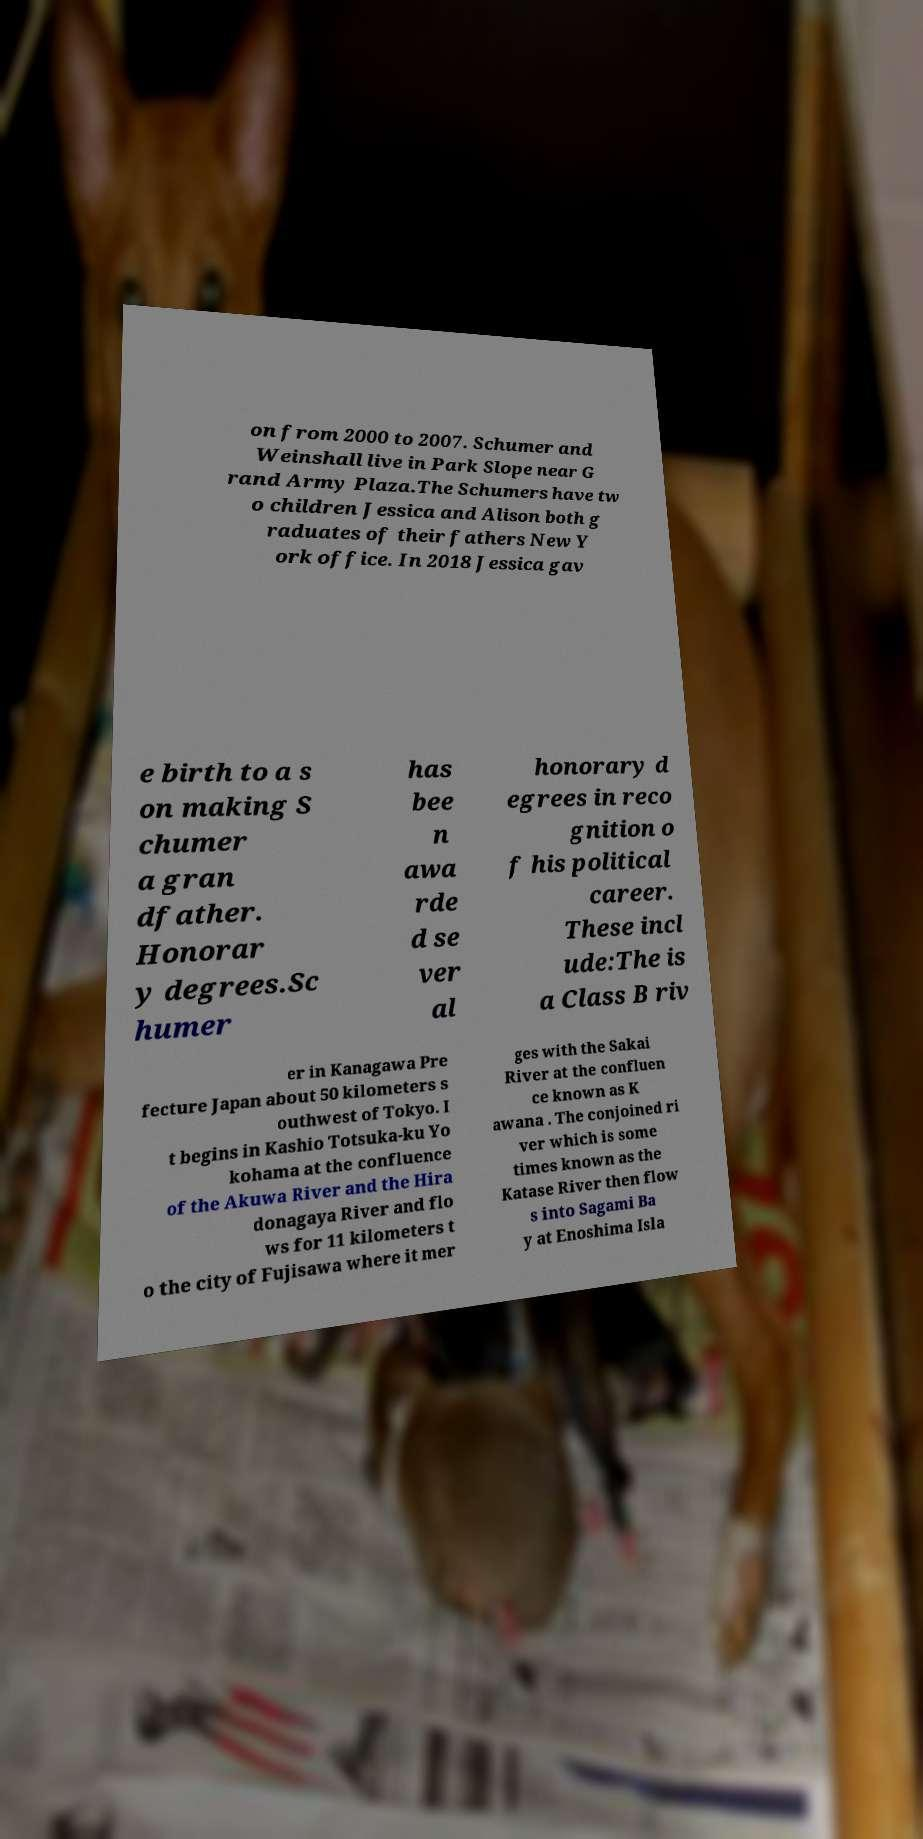For documentation purposes, I need the text within this image transcribed. Could you provide that? on from 2000 to 2007. Schumer and Weinshall live in Park Slope near G rand Army Plaza.The Schumers have tw o children Jessica and Alison both g raduates of their fathers New Y ork office. In 2018 Jessica gav e birth to a s on making S chumer a gran dfather. Honorar y degrees.Sc humer has bee n awa rde d se ver al honorary d egrees in reco gnition o f his political career. These incl ude:The is a Class B riv er in Kanagawa Pre fecture Japan about 50 kilometers s outhwest of Tokyo. I t begins in Kashio Totsuka-ku Yo kohama at the confluence of the Akuwa River and the Hira donagaya River and flo ws for 11 kilometers t o the city of Fujisawa where it mer ges with the Sakai River at the confluen ce known as K awana . The conjoined ri ver which is some times known as the Katase River then flow s into Sagami Ba y at Enoshima Isla 